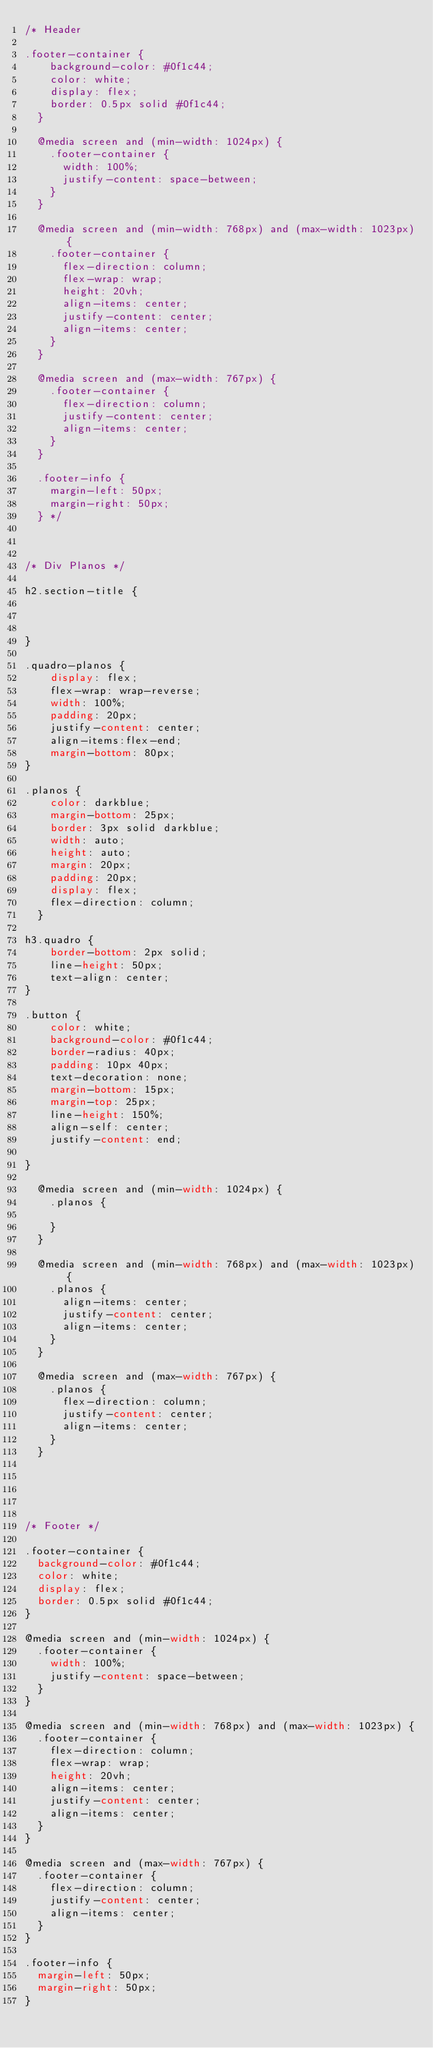Convert code to text. <code><loc_0><loc_0><loc_500><loc_500><_CSS_>/* Header

.footer-container {
    background-color: #0f1c44;
    color: white;
    display: flex;
    border: 0.5px solid #0f1c44;
  }
  
  @media screen and (min-width: 1024px) {
    .footer-container {
      width: 100%;
      justify-content: space-between;
    }
  }
  
  @media screen and (min-width: 768px) and (max-width: 1023px) {
    .footer-container {
      flex-direction: column;
      flex-wrap: wrap;
      height: 20vh;
      align-items: center;
      justify-content: center;
      align-items: center;
    }
  }
  
  @media screen and (max-width: 767px) {
    .footer-container {
      flex-direction: column;
      justify-content: center;
      align-items: center;
    }
  }
  
  .footer-info {
    margin-left: 50px;
    margin-right: 50px;
  } */
  


/* Div Planos */

h2.section-title {
    
    
    
}

.quadro-planos {
    display: flex;
    flex-wrap: wrap-reverse;
    width: 100%;
    padding: 20px;
    justify-content: center;
    align-items:flex-end;
    margin-bottom: 80px;
}

.planos {
    color: darkblue;
    margin-bottom: 25px;
    border: 3px solid darkblue;
    width: auto;
    height: auto;
    margin: 20px;
    padding: 20px;
    display: flex;
    flex-direction: column;
  }

h3.quadro {
    border-bottom: 2px solid;
    line-height: 50px;
    text-align: center;
}

.button {
    color: white;
    background-color: #0f1c44;
    border-radius: 40px;
    padding: 10px 40px;
    text-decoration: none;
    margin-bottom: 15px;
    margin-top: 25px;
    line-height: 150%;
    align-self: center;
    justify-content: end;

}
  
  @media screen and (min-width: 1024px) {
    .planos {

    }
  }
  
  @media screen and (min-width: 768px) and (max-width: 1023px) {
    .planos {
      align-items: center;
      justify-content: center;
      align-items: center;
    }
  }
  
  @media screen and (max-width: 767px) {
    .planos {
      flex-direction: column;
      justify-content: center;
      align-items: center;
    }
  }





/* Footer */

.footer-container {
  background-color: #0f1c44;
  color: white;
  display: flex;
  border: 0.5px solid #0f1c44;
}

@media screen and (min-width: 1024px) {
  .footer-container {
    width: 100%;
    justify-content: space-between;
  }
}

@media screen and (min-width: 768px) and (max-width: 1023px) {
  .footer-container {
    flex-direction: column;
    flex-wrap: wrap;
    height: 20vh;
    align-items: center;
    justify-content: center;
    align-items: center;
  }
}

@media screen and (max-width: 767px) {
  .footer-container {
    flex-direction: column;
    justify-content: center;
    align-items: center;
  }
}

.footer-info {
  margin-left: 50px;
  margin-right: 50px;
}

</code> 